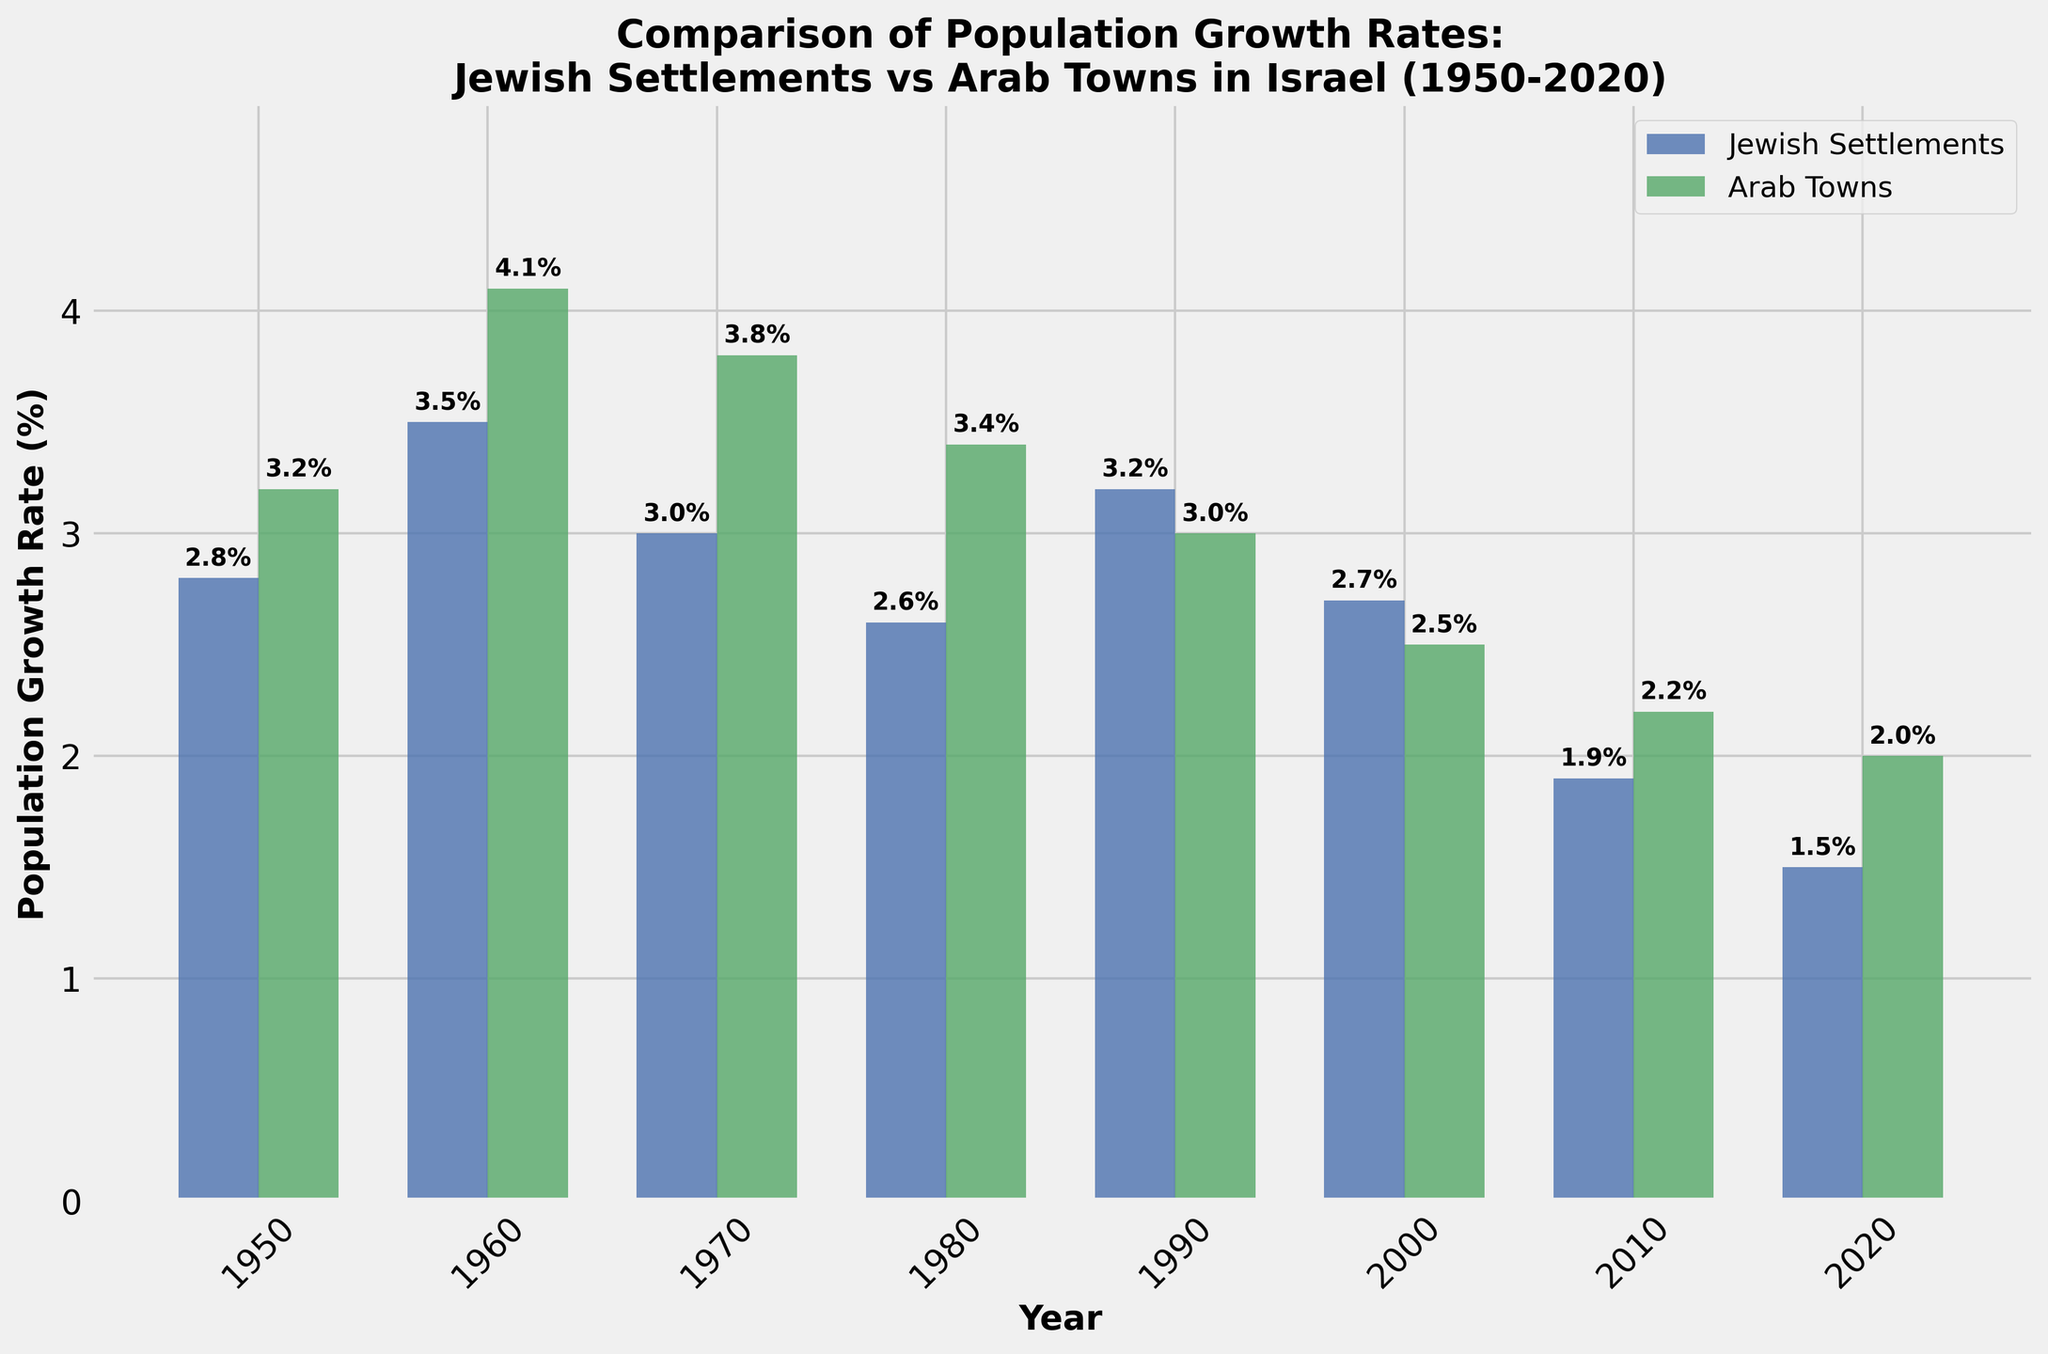What is the population growth rate of Jewish settlements in 1990? Refer to the bar labeled for the year 1990 on the chart. The height of the bar for Jewish settlements indicates the population growth rate.
Answer: 3.2% What year had the highest population growth rate for Arab towns? Look at all the green bars representing Arab towns. Identify the tallest bar and its corresponding year.
Answer: 1960 Which group had a higher population growth rate in 2010, Jewish settlements or Arab towns? Compare the heights of the bars for Jewish settlements and Arab towns for the year 2010. The taller bar represents the group with the higher growth rate.
Answer: Arab towns What is the difference in population growth rates between Jewish settlements and Arab towns in 2000? Subtract the growth rate of Arab towns from the growth rate of Jewish settlements for the year 2000.
Answer: 0.2% Between 1950 and 2020, how many times did the population growth rate of Jewish settlements exceed Arab towns? Compare the bars representing Jewish settlements and Arab towns for each year in the figure. Count the number of years where the Jewish settlements' bar is taller.
Answer: 2 times What is the average population growth rate of Arab towns over the decades shown? Sum the population growth rates of Arab towns for all the years and divide by the number of years (8).
Answer: (3.2+4.1+3.8+3.4+3.0+2.5+2.2+2.0)/8 = 3.03% Which year had the smallest difference in population growth rates between the two groups? Calculate the absolute differences in growth rates for each year. Identify the year with the smallest difference.
Answer: 1990 What trend can be observed in the population growth rates of Jewish settlements from 1950 to 2020? Visually analyze the heights of the blue bars representing Jewish settlements across the years. The trend seems to decrease from 1950 to 2020.
Answer: Decreasing trend What was the overall change in the population growth rate of Arab towns from 1950 to 2020? Subtract the population growth rate of Arab towns in 1950 from that in 2020.
Answer: -1.2% In which year did both groups experience the most similar population growth rates? Calculate the differences in growth rates for each year and determine the year with the smallest difference.
Answer: 1990 